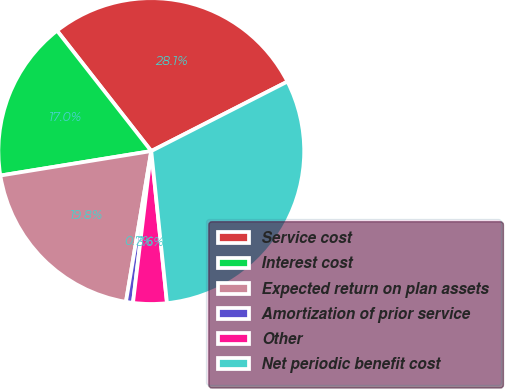Convert chart. <chart><loc_0><loc_0><loc_500><loc_500><pie_chart><fcel>Service cost<fcel>Interest cost<fcel>Expected return on plan assets<fcel>Amortization of prior service<fcel>Other<fcel>Net periodic benefit cost<nl><fcel>28.06%<fcel>16.99%<fcel>19.79%<fcel>0.74%<fcel>3.55%<fcel>30.87%<nl></chart> 